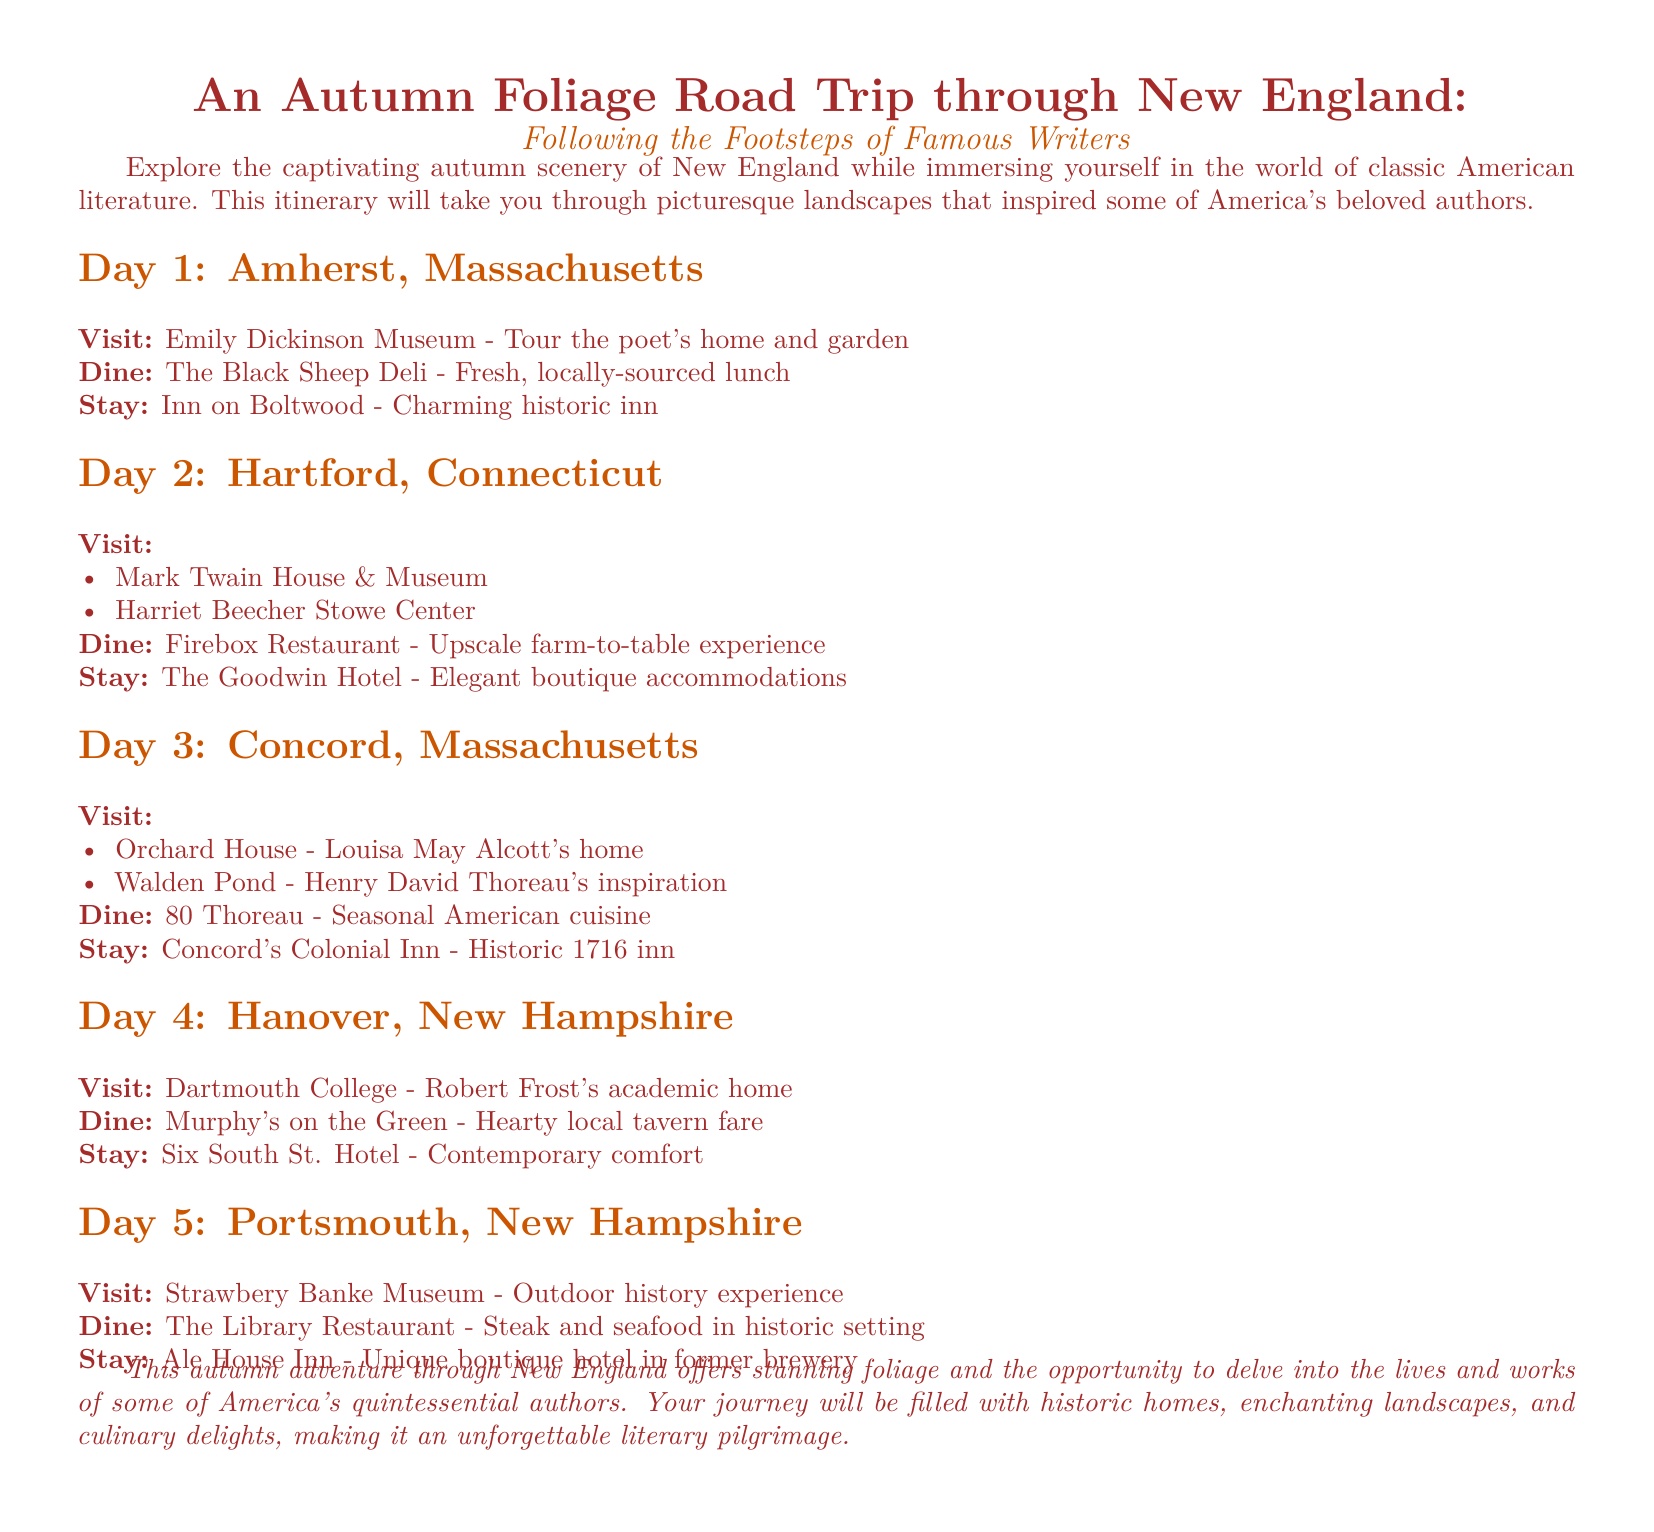What is the name of the hotel in Amherst? The hotel mentioned for accommodation in Amherst is the Inn on Boltwood.
Answer: Inn on Boltwood How many days is the road trip planned for? The itinerary outlines a five-day road trip across New England.
Answer: 5 What is the dining option in Hartford? The upscale dining option provided in Hartford is Firebox Restaurant.
Answer: Firebox Restaurant Which poet's home can be visited in Hanover? Dartmouth College is noted as Robert Frost's academic home, hinting at his connection to the area.
Answer: Robert Frost What is the historical year of Concord's Colonial Inn? The document states that Concord's Colonial Inn dates back to 1716.
Answer: 1716 What type of cuisine does 80 Thoreau serve? The restaurant described in Concord offers seasonal American cuisine.
Answer: Seasonal American cuisine How many sites are suggested to visit in Hartford? Two sites are listed for visiting, the Mark Twain House and the Harriet Beecher Stowe Center.
Answer: 2 What unique feature does Ale House Inn offer? The Ale House Inn is described as a unique boutique hotel located in a former brewery.
Answer: Former brewery What outdoor attraction is mentioned in Portsmouth? The Strawbery Banke Museum is noted for providing an outdoor history experience.
Answer: Strawbery Banke Museum 